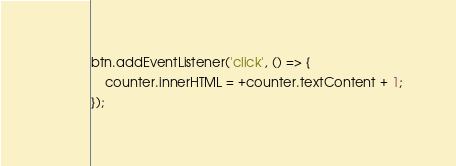<code> <loc_0><loc_0><loc_500><loc_500><_JavaScript_>btn.addEventListener('click', () => {
    counter.innerHTML = +counter.textContent + 1;
});</code> 